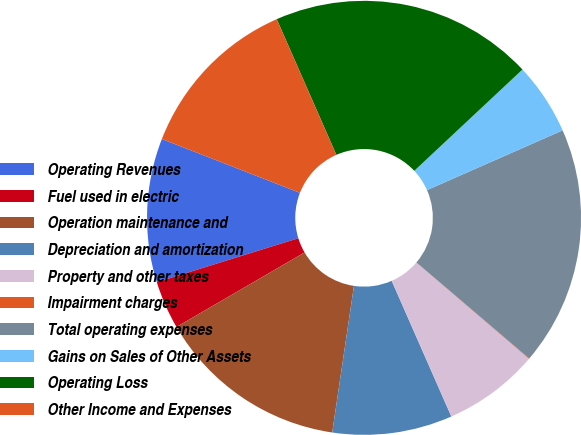<chart> <loc_0><loc_0><loc_500><loc_500><pie_chart><fcel>Operating Revenues<fcel>Fuel used in electric<fcel>Operation maintenance and<fcel>Depreciation and amortization<fcel>Property and other taxes<fcel>Impairment charges<fcel>Total operating expenses<fcel>Gains on Sales of Other Assets<fcel>Operating Loss<fcel>Other Income and Expenses<nl><fcel>10.71%<fcel>3.59%<fcel>14.27%<fcel>8.93%<fcel>7.15%<fcel>0.03%<fcel>17.83%<fcel>5.37%<fcel>19.61%<fcel>12.49%<nl></chart> 